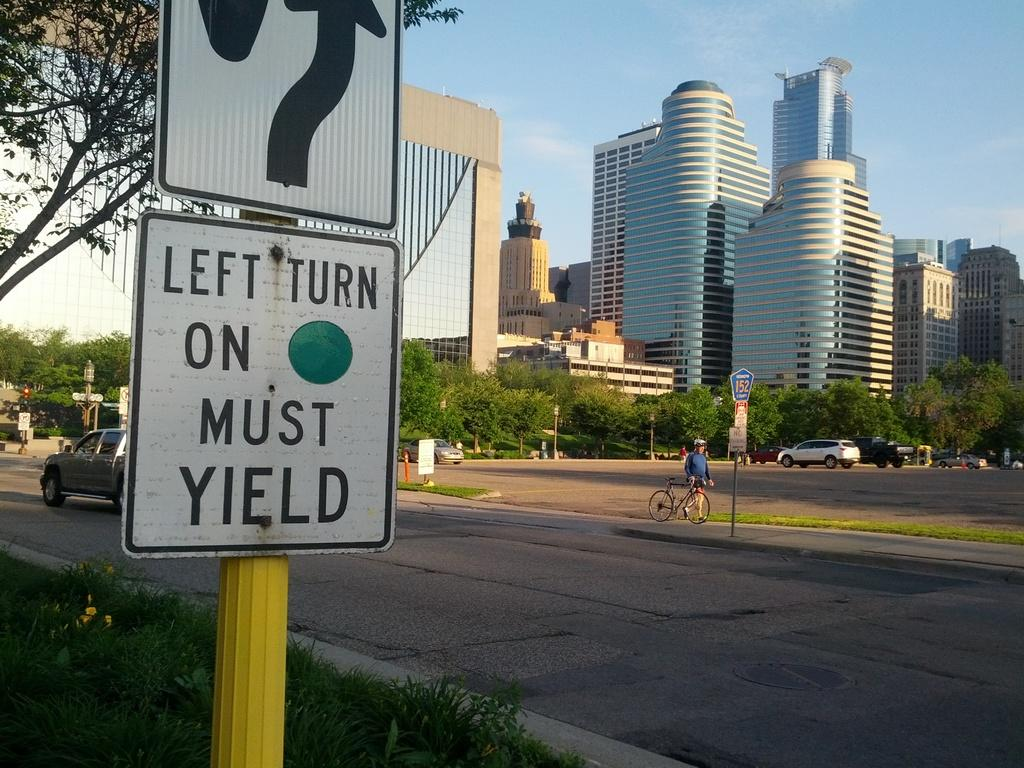<image>
Summarize the visual content of the image. A road sign tells motorists to yield at the left turn. 